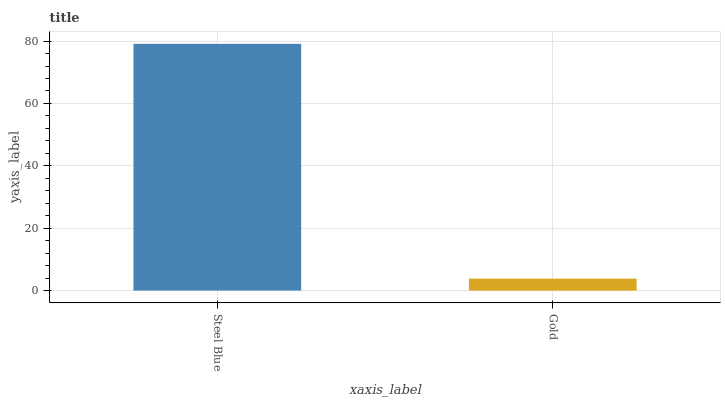Is Gold the minimum?
Answer yes or no. Yes. Is Steel Blue the maximum?
Answer yes or no. Yes. Is Gold the maximum?
Answer yes or no. No. Is Steel Blue greater than Gold?
Answer yes or no. Yes. Is Gold less than Steel Blue?
Answer yes or no. Yes. Is Gold greater than Steel Blue?
Answer yes or no. No. Is Steel Blue less than Gold?
Answer yes or no. No. Is Steel Blue the high median?
Answer yes or no. Yes. Is Gold the low median?
Answer yes or no. Yes. Is Gold the high median?
Answer yes or no. No. Is Steel Blue the low median?
Answer yes or no. No. 